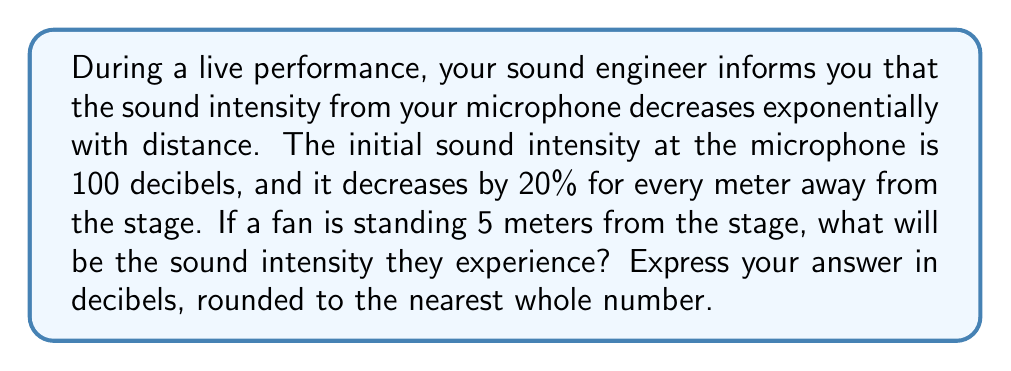What is the answer to this math problem? Let's approach this step-by-step:

1) First, we need to identify the exponential function that models this situation. The general form of an exponential decay function is:

   $$I(x) = I_0 \cdot (1-r)^x$$

   Where:
   $I(x)$ is the intensity at distance $x$
   $I_0$ is the initial intensity
   $r$ is the rate of decay per unit distance
   $x$ is the distance

2) We know:
   $I_0 = 100$ decibels
   $r = 0.20$ (20% decrease per meter)
   $x = 5$ meters

3) Plugging these values into our function:

   $$I(5) = 100 \cdot (1-0.20)^5$$

4) Simplify inside the parentheses:

   $$I(5) = 100 \cdot (0.80)^5$$

5) Calculate $(0.80)^5$:

   $$I(5) = 100 \cdot 0.32768$$

6) Multiply:

   $$I(5) = 32.768$$

7) Round to the nearest whole number:

   $$I(5) \approx 33$$ decibels
Answer: 33 decibels 